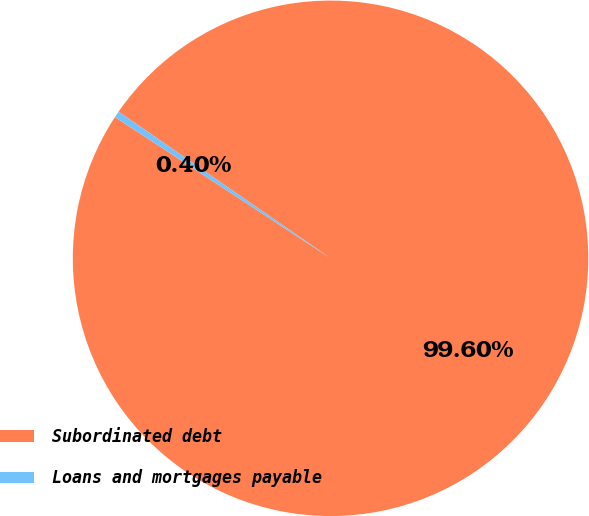<chart> <loc_0><loc_0><loc_500><loc_500><pie_chart><fcel>Subordinated debt<fcel>Loans and mortgages payable<nl><fcel>99.6%<fcel>0.4%<nl></chart> 